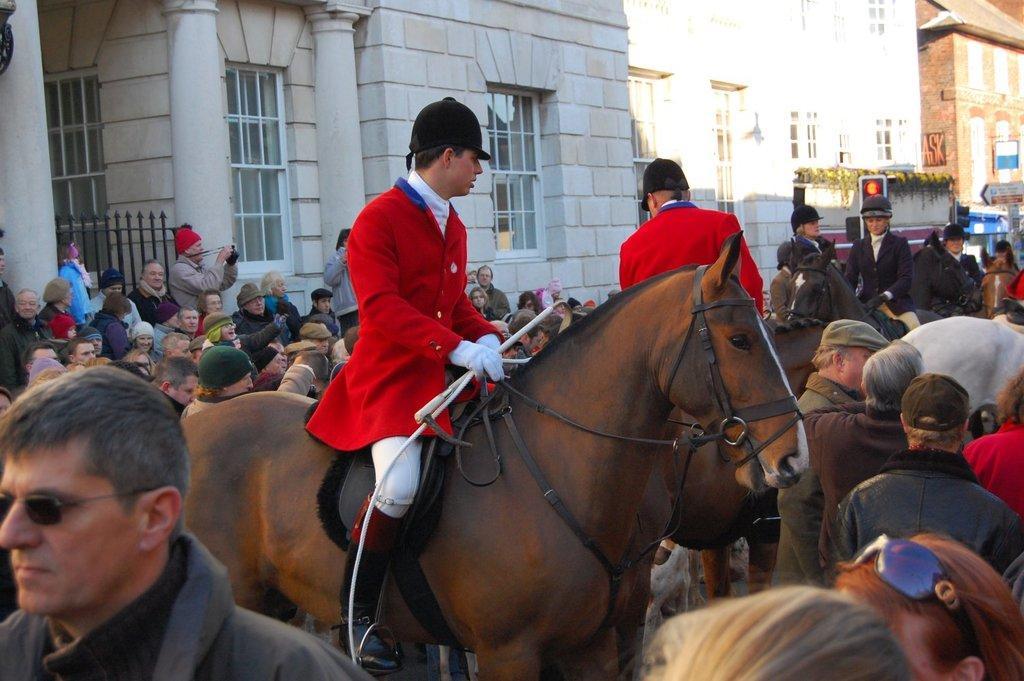How would you summarize this image in a sentence or two? In this image there are many people standing on the road and some are sitting on the horse. In the background there are buildings. 